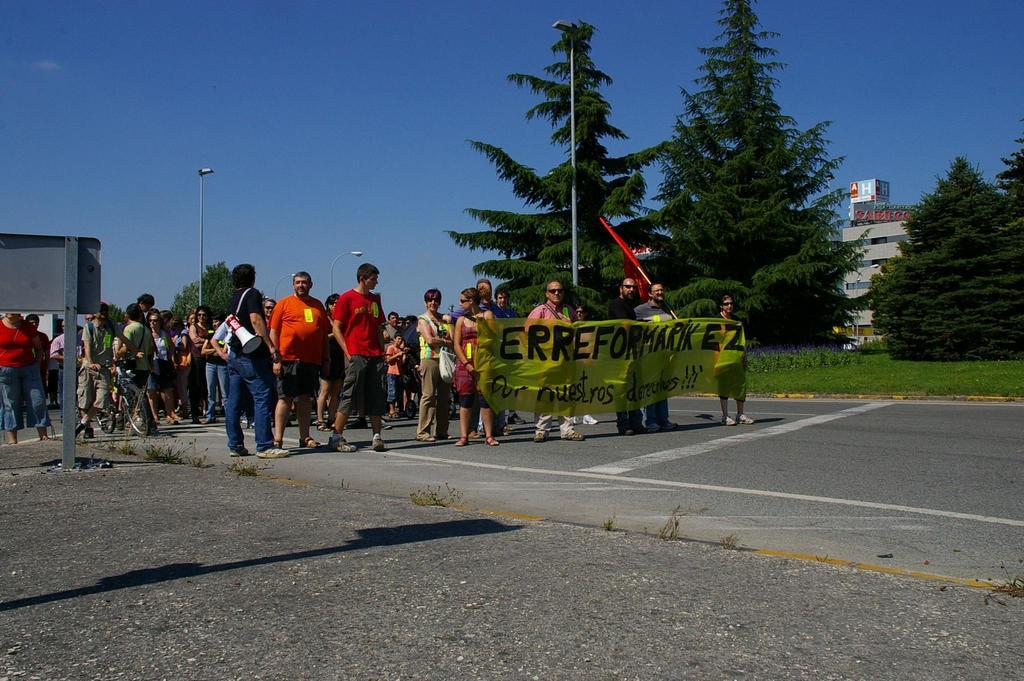<image>
Write a terse but informative summary of the picture. People are holding up a banner that says Erreformarik EZ on it. 